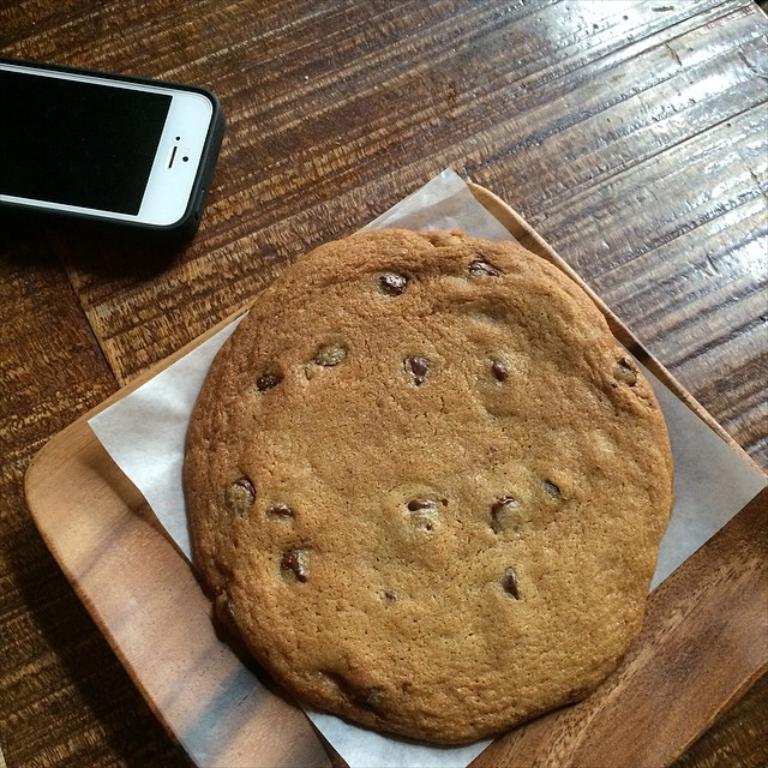How would you summarize this image in a sentence or two? In this picture, we see a plate containing edible and tissue is placed on the brown color table. We even see mobile phone which is placed on that table. 